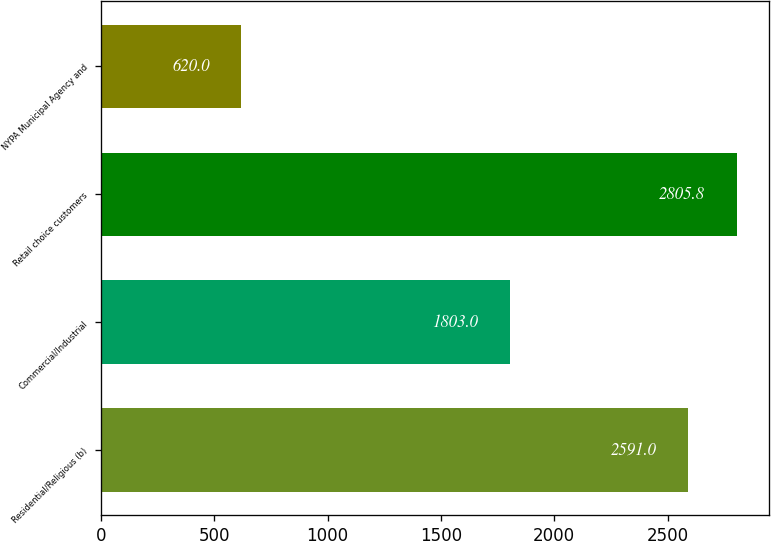Convert chart to OTSL. <chart><loc_0><loc_0><loc_500><loc_500><bar_chart><fcel>Residential/Religious (b)<fcel>Commercial/Industrial<fcel>Retail choice customers<fcel>NYPA Municipal Agency and<nl><fcel>2591<fcel>1803<fcel>2805.8<fcel>620<nl></chart> 